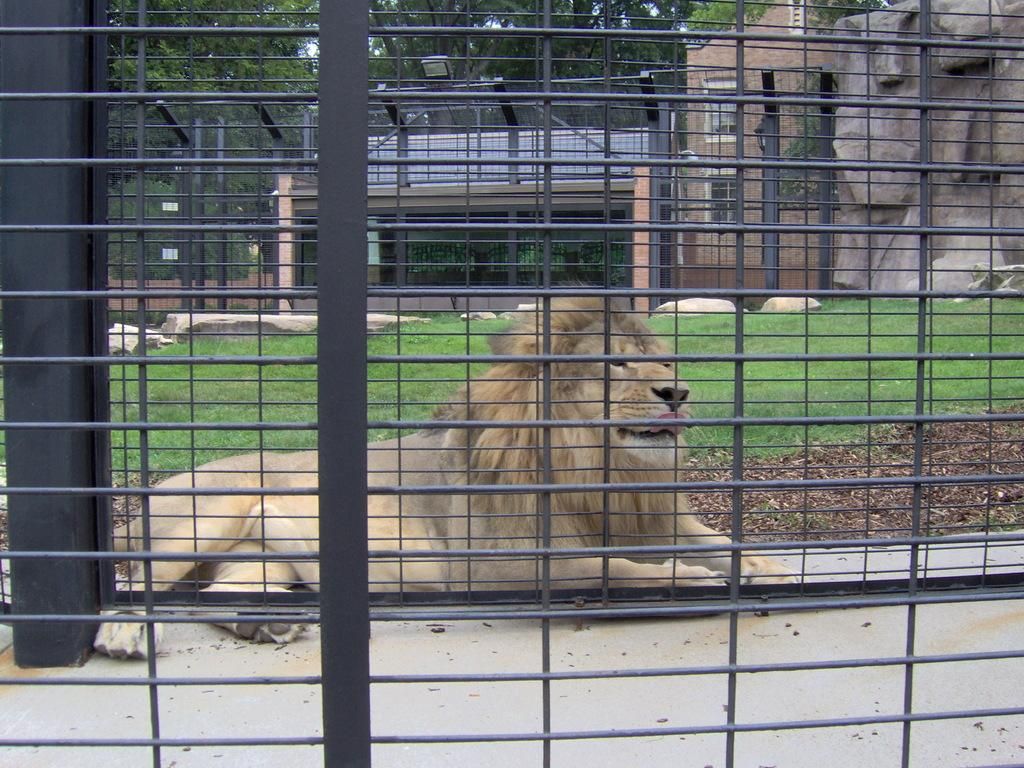What animal is in the cage in the foreground of the image? There is a lion in a cage in the foreground of the image. What type of terrain is visible in the image? There are stones, grassland, and trees visible in the image. What structures can be seen in the background of the image? There is a hose structure and a lamp in the background of the image. What type of snow can be seen falling in the image? There is no snow present in the image; it features a lion in a cage, stones, grassland, trees, a hose structure, and a lamp. 